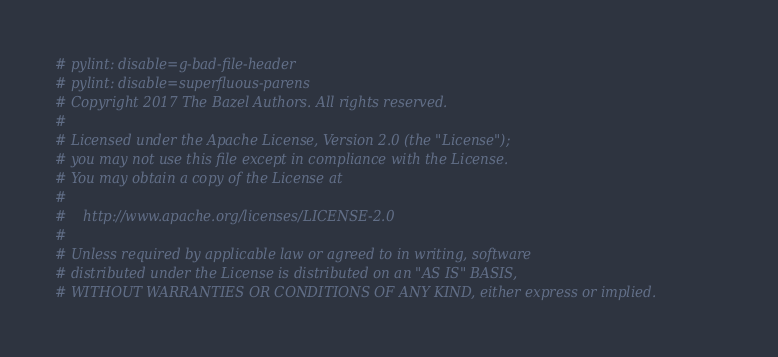<code> <loc_0><loc_0><loc_500><loc_500><_Python_># pylint: disable=g-bad-file-header
# pylint: disable=superfluous-parens
# Copyright 2017 The Bazel Authors. All rights reserved.
#
# Licensed under the Apache License, Version 2.0 (the "License");
# you may not use this file except in compliance with the License.
# You may obtain a copy of the License at
#
#    http://www.apache.org/licenses/LICENSE-2.0
#
# Unless required by applicable law or agreed to in writing, software
# distributed under the License is distributed on an "AS IS" BASIS,
# WITHOUT WARRANTIES OR CONDITIONS OF ANY KIND, either express or implied.</code> 